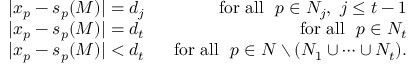<formula> <loc_0><loc_0><loc_500><loc_500>\begin{array} { r l r } & { | x _ { p } - s _ { p } ( M ) | = d _ { j } } & { f o r a l l p \in N _ { j } , j \leq t - 1 } \\ & { | x _ { p } - s _ { p } ( M ) | = d _ { t } } & { f o r a l l p \in N _ { t } } \\ & { | x _ { p } - s _ { p } ( M ) | < d _ { t } } & { f o r a l l p \in N \ ( N _ { 1 } \cup \dots \cup N _ { t } ) . } \end{array}</formula> 